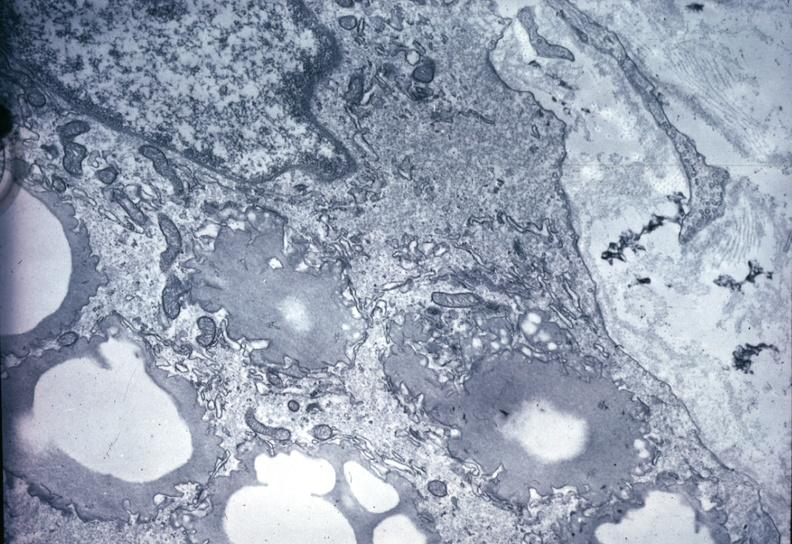s cardiovascular present?
Answer the question using a single word or phrase. Yes 